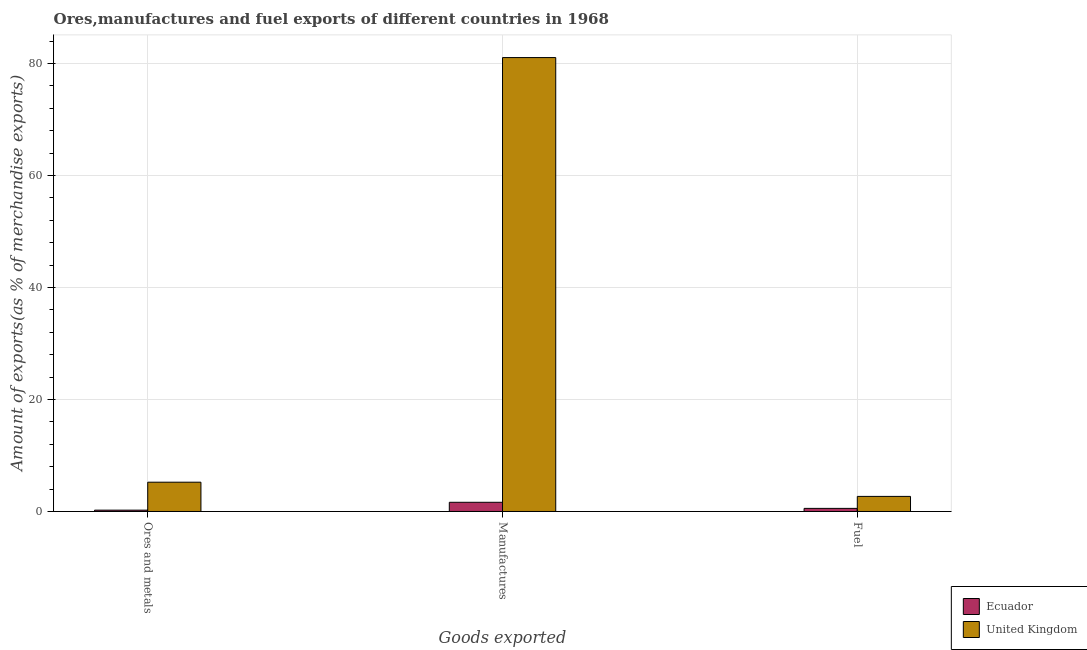How many different coloured bars are there?
Ensure brevity in your answer.  2. Are the number of bars per tick equal to the number of legend labels?
Your answer should be compact. Yes. Are the number of bars on each tick of the X-axis equal?
Keep it short and to the point. Yes. How many bars are there on the 1st tick from the left?
Your response must be concise. 2. What is the label of the 2nd group of bars from the left?
Offer a terse response. Manufactures. What is the percentage of fuel exports in United Kingdom?
Provide a short and direct response. 2.7. Across all countries, what is the maximum percentage of manufactures exports?
Offer a terse response. 81.07. Across all countries, what is the minimum percentage of fuel exports?
Make the answer very short. 0.55. In which country was the percentage of fuel exports minimum?
Offer a terse response. Ecuador. What is the total percentage of fuel exports in the graph?
Your answer should be very brief. 3.25. What is the difference between the percentage of fuel exports in Ecuador and that in United Kingdom?
Your answer should be compact. -2.14. What is the difference between the percentage of ores and metals exports in Ecuador and the percentage of fuel exports in United Kingdom?
Offer a very short reply. -2.46. What is the average percentage of ores and metals exports per country?
Make the answer very short. 2.74. What is the difference between the percentage of fuel exports and percentage of manufactures exports in United Kingdom?
Keep it short and to the point. -78.37. What is the ratio of the percentage of manufactures exports in United Kingdom to that in Ecuador?
Your response must be concise. 49.36. Is the percentage of ores and metals exports in United Kingdom less than that in Ecuador?
Provide a succinct answer. No. What is the difference between the highest and the second highest percentage of ores and metals exports?
Give a very brief answer. 4.99. What is the difference between the highest and the lowest percentage of ores and metals exports?
Your answer should be very brief. 4.99. In how many countries, is the percentage of fuel exports greater than the average percentage of fuel exports taken over all countries?
Make the answer very short. 1. What does the 2nd bar from the right in Ores and metals represents?
Provide a succinct answer. Ecuador. How many bars are there?
Your answer should be very brief. 6. How many countries are there in the graph?
Give a very brief answer. 2. Are the values on the major ticks of Y-axis written in scientific E-notation?
Provide a short and direct response. No. Where does the legend appear in the graph?
Keep it short and to the point. Bottom right. What is the title of the graph?
Offer a very short reply. Ores,manufactures and fuel exports of different countries in 1968. Does "Argentina" appear as one of the legend labels in the graph?
Offer a terse response. No. What is the label or title of the X-axis?
Your answer should be very brief. Goods exported. What is the label or title of the Y-axis?
Offer a terse response. Amount of exports(as % of merchandise exports). What is the Amount of exports(as % of merchandise exports) of Ecuador in Ores and metals?
Give a very brief answer. 0.24. What is the Amount of exports(as % of merchandise exports) of United Kingdom in Ores and metals?
Provide a succinct answer. 5.23. What is the Amount of exports(as % of merchandise exports) in Ecuador in Manufactures?
Make the answer very short. 1.64. What is the Amount of exports(as % of merchandise exports) of United Kingdom in Manufactures?
Your answer should be very brief. 81.07. What is the Amount of exports(as % of merchandise exports) in Ecuador in Fuel?
Offer a very short reply. 0.55. What is the Amount of exports(as % of merchandise exports) of United Kingdom in Fuel?
Your response must be concise. 2.7. Across all Goods exported, what is the maximum Amount of exports(as % of merchandise exports) of Ecuador?
Offer a very short reply. 1.64. Across all Goods exported, what is the maximum Amount of exports(as % of merchandise exports) of United Kingdom?
Provide a succinct answer. 81.07. Across all Goods exported, what is the minimum Amount of exports(as % of merchandise exports) in Ecuador?
Your answer should be compact. 0.24. Across all Goods exported, what is the minimum Amount of exports(as % of merchandise exports) of United Kingdom?
Give a very brief answer. 2.7. What is the total Amount of exports(as % of merchandise exports) of Ecuador in the graph?
Offer a very short reply. 2.43. What is the total Amount of exports(as % of merchandise exports) of United Kingdom in the graph?
Offer a terse response. 88.99. What is the difference between the Amount of exports(as % of merchandise exports) of Ecuador in Ores and metals and that in Manufactures?
Your response must be concise. -1.4. What is the difference between the Amount of exports(as % of merchandise exports) of United Kingdom in Ores and metals and that in Manufactures?
Make the answer very short. -75.84. What is the difference between the Amount of exports(as % of merchandise exports) in Ecuador in Ores and metals and that in Fuel?
Ensure brevity in your answer.  -0.31. What is the difference between the Amount of exports(as % of merchandise exports) in United Kingdom in Ores and metals and that in Fuel?
Keep it short and to the point. 2.54. What is the difference between the Amount of exports(as % of merchandise exports) in Ecuador in Manufactures and that in Fuel?
Provide a short and direct response. 1.09. What is the difference between the Amount of exports(as % of merchandise exports) in United Kingdom in Manufactures and that in Fuel?
Offer a very short reply. 78.37. What is the difference between the Amount of exports(as % of merchandise exports) in Ecuador in Ores and metals and the Amount of exports(as % of merchandise exports) in United Kingdom in Manufactures?
Provide a succinct answer. -80.83. What is the difference between the Amount of exports(as % of merchandise exports) of Ecuador in Ores and metals and the Amount of exports(as % of merchandise exports) of United Kingdom in Fuel?
Offer a very short reply. -2.46. What is the difference between the Amount of exports(as % of merchandise exports) of Ecuador in Manufactures and the Amount of exports(as % of merchandise exports) of United Kingdom in Fuel?
Provide a succinct answer. -1.05. What is the average Amount of exports(as % of merchandise exports) in Ecuador per Goods exported?
Your answer should be compact. 0.81. What is the average Amount of exports(as % of merchandise exports) of United Kingdom per Goods exported?
Your answer should be compact. 29.66. What is the difference between the Amount of exports(as % of merchandise exports) in Ecuador and Amount of exports(as % of merchandise exports) in United Kingdom in Ores and metals?
Your answer should be compact. -4.99. What is the difference between the Amount of exports(as % of merchandise exports) of Ecuador and Amount of exports(as % of merchandise exports) of United Kingdom in Manufactures?
Make the answer very short. -79.42. What is the difference between the Amount of exports(as % of merchandise exports) in Ecuador and Amount of exports(as % of merchandise exports) in United Kingdom in Fuel?
Offer a very short reply. -2.14. What is the ratio of the Amount of exports(as % of merchandise exports) of Ecuador in Ores and metals to that in Manufactures?
Your answer should be very brief. 0.15. What is the ratio of the Amount of exports(as % of merchandise exports) in United Kingdom in Ores and metals to that in Manufactures?
Ensure brevity in your answer.  0.06. What is the ratio of the Amount of exports(as % of merchandise exports) of Ecuador in Ores and metals to that in Fuel?
Offer a very short reply. 0.43. What is the ratio of the Amount of exports(as % of merchandise exports) in United Kingdom in Ores and metals to that in Fuel?
Your answer should be compact. 1.94. What is the ratio of the Amount of exports(as % of merchandise exports) in Ecuador in Manufactures to that in Fuel?
Make the answer very short. 2.97. What is the ratio of the Amount of exports(as % of merchandise exports) in United Kingdom in Manufactures to that in Fuel?
Provide a short and direct response. 30.08. What is the difference between the highest and the second highest Amount of exports(as % of merchandise exports) in Ecuador?
Your answer should be compact. 1.09. What is the difference between the highest and the second highest Amount of exports(as % of merchandise exports) of United Kingdom?
Make the answer very short. 75.84. What is the difference between the highest and the lowest Amount of exports(as % of merchandise exports) in Ecuador?
Your response must be concise. 1.4. What is the difference between the highest and the lowest Amount of exports(as % of merchandise exports) in United Kingdom?
Keep it short and to the point. 78.37. 